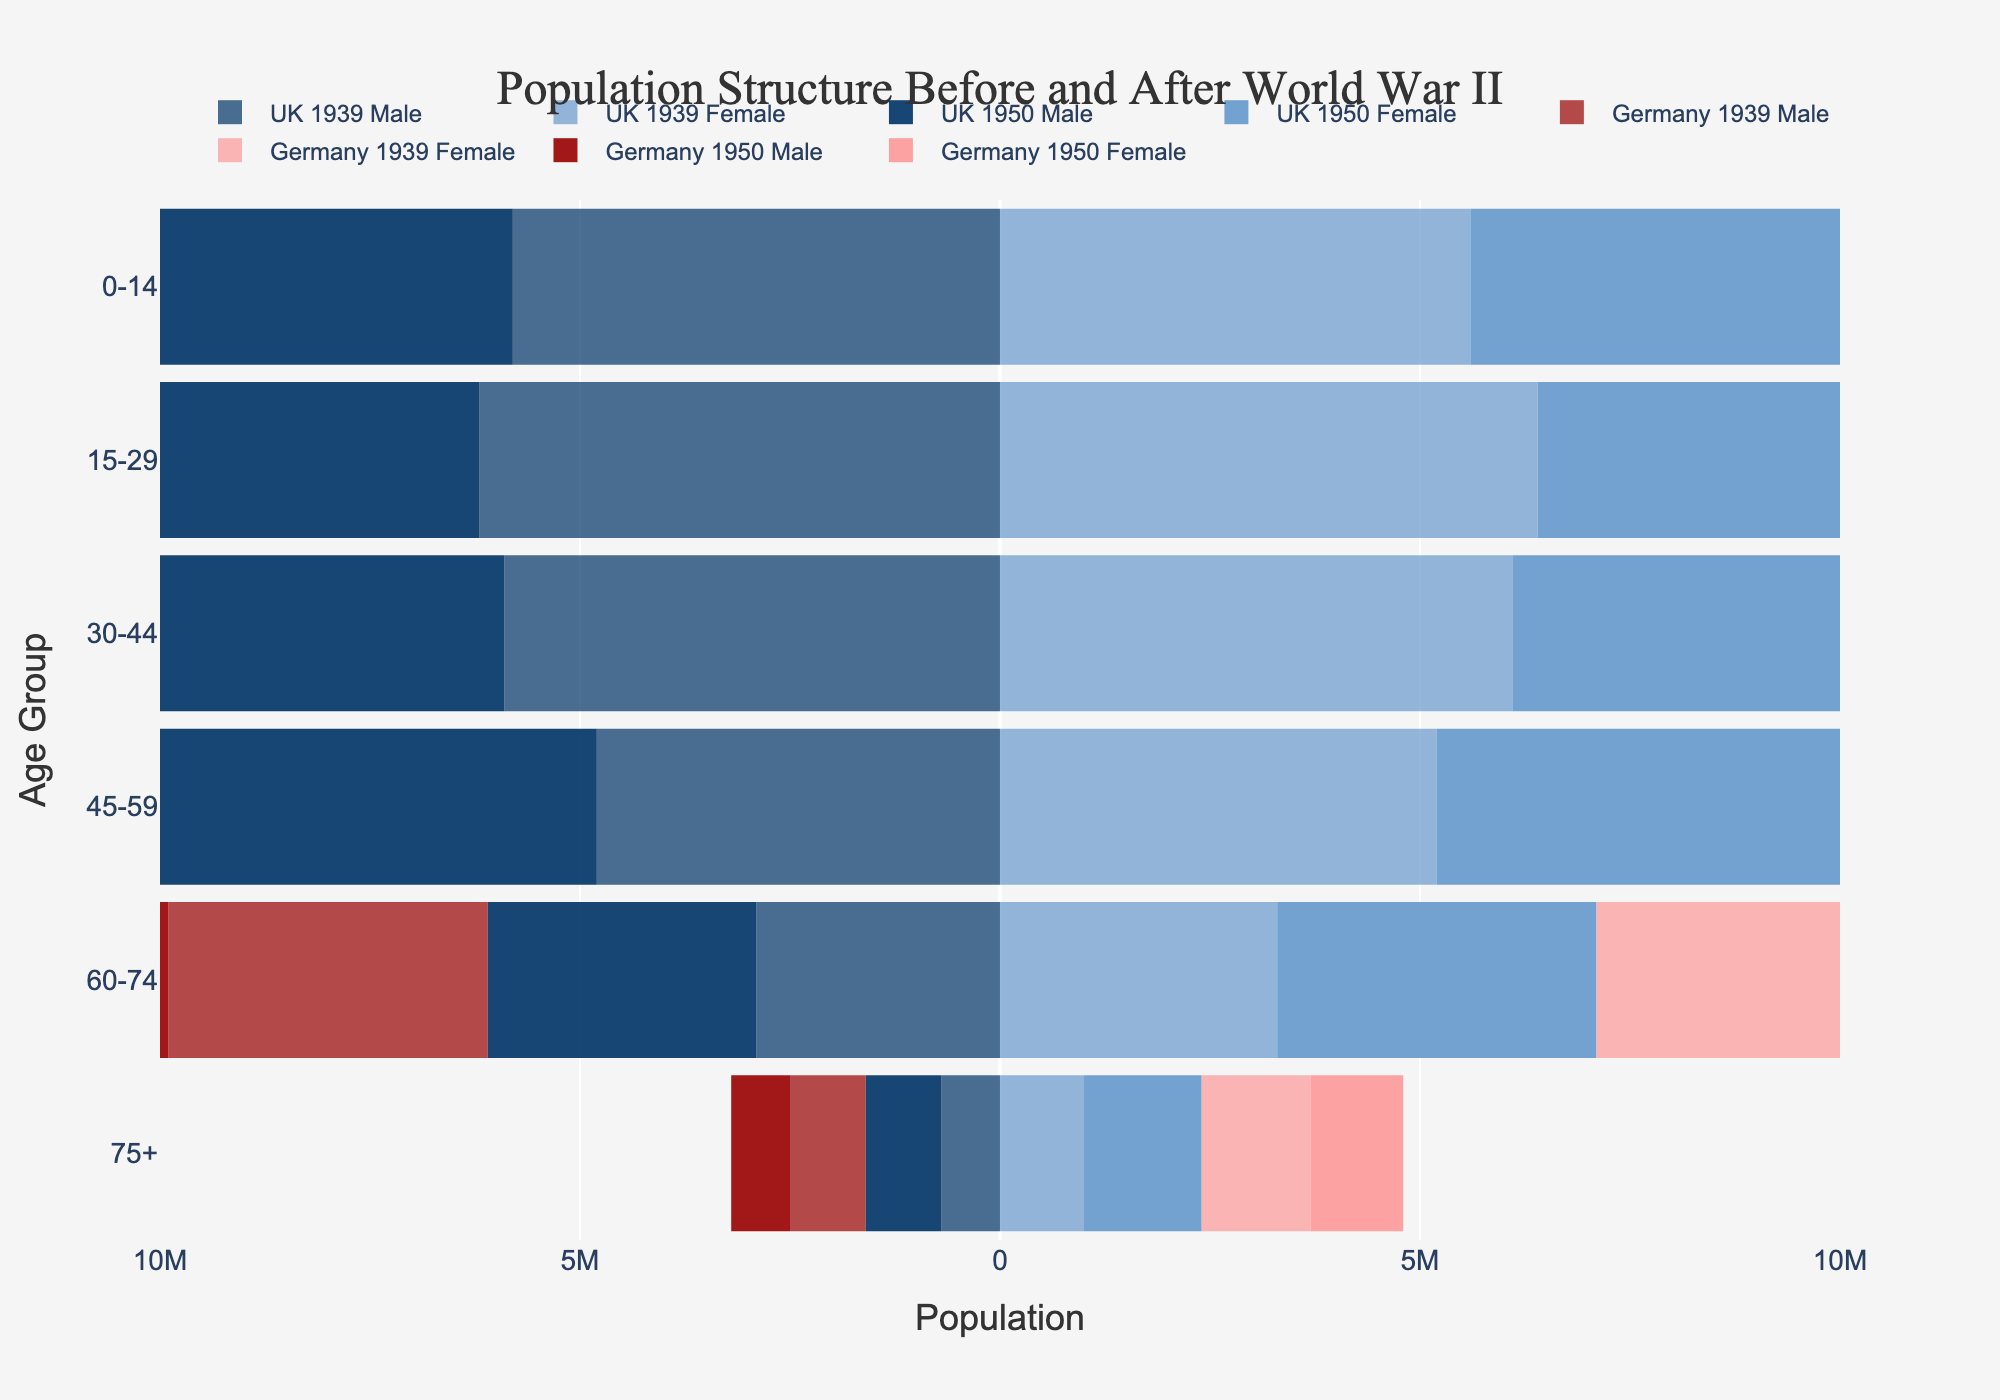What is the title of the plot? The title can be seen at the top of the figure, usually in larger font size to attract attention. Here, the title is clearly indicated.
Answer: Population Structure Before and After World War II Which country had a higher male population in the age group 0-14 years in 1939? To determine this, look at the bars representing males aged 0-14 in 1939 for both countries. Compare their lengths to see which is longer.
Answer: Germany How did the population of UK females aged 75+ change from 1939 to 1950? Compare the lengths of the bars for UK females aged 75+ in 1939 and 1950. Determine if the bar for 1950 is longer, shorter, or the same as in 1939.
Answer: Increased What is the approximate difference in the total male population of age group 30-44 between UK and Germany in 1950? Look at the lengths of the bars representing males aged 30-44 in 1950 for both countries. Subtract the length of the UK's bar from the length of Germany's bar (absolute values).
Answer: 500,000 In which year did Germany see a larger female population in the age group 45-59? Compare the lengths of the bars for German females aged 45-59 in 1939 and 1950. Determine which bar is longer.
Answer: 1939 Which country had a more balanced male-to-female ratio in the 30-44 age group in 1950? Examine the lengths of the bars for both males and females in the 30-44 age group for both countries in 1950. Determine which country's male and female bars are more equal in length.
Answer: UK How did World War II affect the male population in Germany across all age groups? Observe the bars representing German males for both 1939 and 1950. Note which bars got shorter, indicating a decrease in population, across all age groups.
Answer: Decreased In the age group 15-29, which year saw a higher female population in the UK? Compare the lengths of the bars for UK females aged 15-29 in 1939 and 1950. Determine which bar is longer.
Answer: 1939 Calculate the total female population in the UK for 1939 for all age groups. Add the lengths of all the bars representing UK females in 1939 to get the total population.
Answer: 27,600,000 Did the UK's population structure change more significantly for males or females between 1939 and 1950? Compare the changes in bar lengths for UK males and females between 1939 and 1950 across all age groups. Determine whether males or females show more significant changes in bar lengths.
Answer: Females 